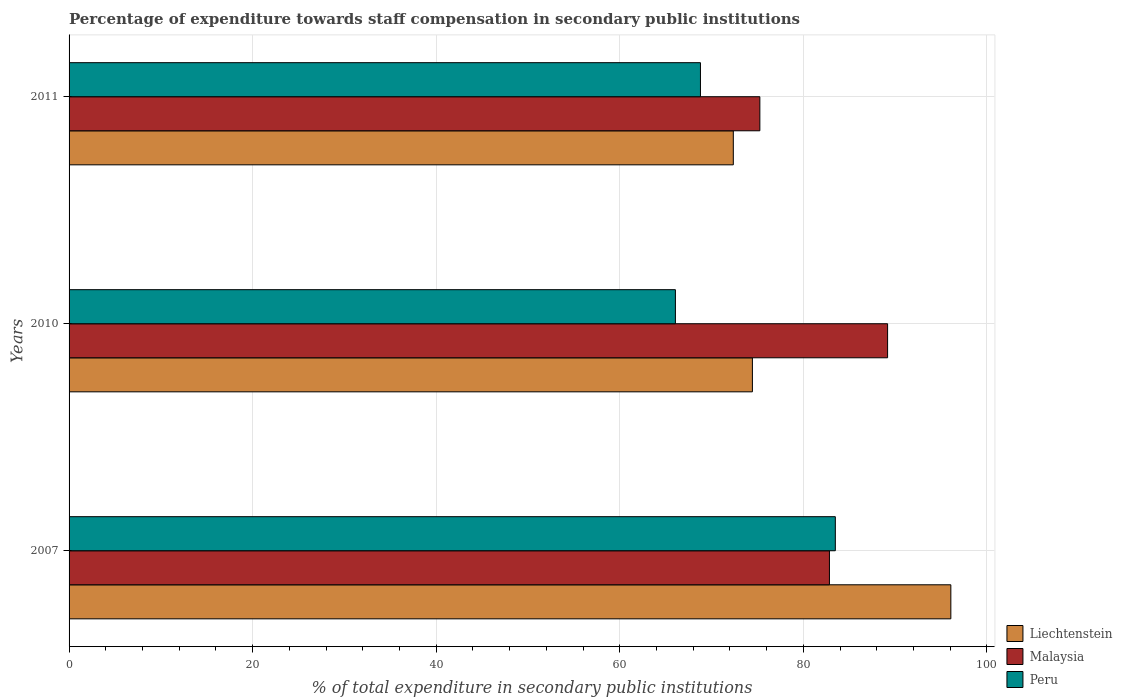How many different coloured bars are there?
Offer a very short reply. 3. Are the number of bars on each tick of the Y-axis equal?
Offer a terse response. Yes. How many bars are there on the 3rd tick from the top?
Give a very brief answer. 3. How many bars are there on the 2nd tick from the bottom?
Your response must be concise. 3. What is the label of the 2nd group of bars from the top?
Your response must be concise. 2010. What is the percentage of expenditure towards staff compensation in Peru in 2010?
Provide a succinct answer. 66.06. Across all years, what is the maximum percentage of expenditure towards staff compensation in Liechtenstein?
Offer a very short reply. 96.07. Across all years, what is the minimum percentage of expenditure towards staff compensation in Liechtenstein?
Provide a succinct answer. 72.37. In which year was the percentage of expenditure towards staff compensation in Malaysia maximum?
Give a very brief answer. 2010. What is the total percentage of expenditure towards staff compensation in Peru in the graph?
Your answer should be compact. 218.34. What is the difference between the percentage of expenditure towards staff compensation in Malaysia in 2007 and that in 2011?
Ensure brevity in your answer.  7.58. What is the difference between the percentage of expenditure towards staff compensation in Liechtenstein in 2010 and the percentage of expenditure towards staff compensation in Peru in 2007?
Offer a terse response. -9.03. What is the average percentage of expenditure towards staff compensation in Liechtenstein per year?
Ensure brevity in your answer.  80.97. In the year 2010, what is the difference between the percentage of expenditure towards staff compensation in Liechtenstein and percentage of expenditure towards staff compensation in Peru?
Give a very brief answer. 8.39. What is the ratio of the percentage of expenditure towards staff compensation in Liechtenstein in 2007 to that in 2011?
Your answer should be compact. 1.33. Is the difference between the percentage of expenditure towards staff compensation in Liechtenstein in 2007 and 2010 greater than the difference between the percentage of expenditure towards staff compensation in Peru in 2007 and 2010?
Provide a short and direct response. Yes. What is the difference between the highest and the second highest percentage of expenditure towards staff compensation in Liechtenstein?
Your response must be concise. 21.62. What is the difference between the highest and the lowest percentage of expenditure towards staff compensation in Liechtenstein?
Make the answer very short. 23.7. Is the sum of the percentage of expenditure towards staff compensation in Liechtenstein in 2010 and 2011 greater than the maximum percentage of expenditure towards staff compensation in Peru across all years?
Offer a terse response. Yes. What does the 2nd bar from the top in 2010 represents?
Make the answer very short. Malaysia. What does the 1st bar from the bottom in 2010 represents?
Your answer should be very brief. Liechtenstein. How many years are there in the graph?
Your response must be concise. 3. What is the difference between two consecutive major ticks on the X-axis?
Provide a succinct answer. 20. Does the graph contain any zero values?
Keep it short and to the point. No. How are the legend labels stacked?
Provide a short and direct response. Vertical. What is the title of the graph?
Offer a very short reply. Percentage of expenditure towards staff compensation in secondary public institutions. What is the label or title of the X-axis?
Your response must be concise. % of total expenditure in secondary public institutions. What is the label or title of the Y-axis?
Keep it short and to the point. Years. What is the % of total expenditure in secondary public institutions of Liechtenstein in 2007?
Your answer should be compact. 96.07. What is the % of total expenditure in secondary public institutions of Malaysia in 2007?
Your answer should be very brief. 82.85. What is the % of total expenditure in secondary public institutions of Peru in 2007?
Provide a succinct answer. 83.49. What is the % of total expenditure in secondary public institutions in Liechtenstein in 2010?
Offer a very short reply. 74.45. What is the % of total expenditure in secondary public institutions of Malaysia in 2010?
Provide a short and direct response. 89.18. What is the % of total expenditure in secondary public institutions of Peru in 2010?
Provide a short and direct response. 66.06. What is the % of total expenditure in secondary public institutions in Liechtenstein in 2011?
Offer a terse response. 72.37. What is the % of total expenditure in secondary public institutions of Malaysia in 2011?
Ensure brevity in your answer.  75.26. What is the % of total expenditure in secondary public institutions of Peru in 2011?
Your response must be concise. 68.79. Across all years, what is the maximum % of total expenditure in secondary public institutions in Liechtenstein?
Your answer should be compact. 96.07. Across all years, what is the maximum % of total expenditure in secondary public institutions in Malaysia?
Offer a terse response. 89.18. Across all years, what is the maximum % of total expenditure in secondary public institutions in Peru?
Ensure brevity in your answer.  83.49. Across all years, what is the minimum % of total expenditure in secondary public institutions of Liechtenstein?
Your answer should be compact. 72.37. Across all years, what is the minimum % of total expenditure in secondary public institutions of Malaysia?
Offer a terse response. 75.26. Across all years, what is the minimum % of total expenditure in secondary public institutions in Peru?
Ensure brevity in your answer.  66.06. What is the total % of total expenditure in secondary public institutions of Liechtenstein in the graph?
Ensure brevity in your answer.  242.9. What is the total % of total expenditure in secondary public institutions in Malaysia in the graph?
Give a very brief answer. 247.29. What is the total % of total expenditure in secondary public institutions of Peru in the graph?
Your answer should be very brief. 218.34. What is the difference between the % of total expenditure in secondary public institutions in Liechtenstein in 2007 and that in 2010?
Your response must be concise. 21.62. What is the difference between the % of total expenditure in secondary public institutions of Malaysia in 2007 and that in 2010?
Offer a very short reply. -6.34. What is the difference between the % of total expenditure in secondary public institutions of Peru in 2007 and that in 2010?
Provide a succinct answer. 17.42. What is the difference between the % of total expenditure in secondary public institutions in Liechtenstein in 2007 and that in 2011?
Provide a short and direct response. 23.7. What is the difference between the % of total expenditure in secondary public institutions of Malaysia in 2007 and that in 2011?
Ensure brevity in your answer.  7.58. What is the difference between the % of total expenditure in secondary public institutions in Peru in 2007 and that in 2011?
Make the answer very short. 14.7. What is the difference between the % of total expenditure in secondary public institutions of Liechtenstein in 2010 and that in 2011?
Make the answer very short. 2.08. What is the difference between the % of total expenditure in secondary public institutions of Malaysia in 2010 and that in 2011?
Your response must be concise. 13.92. What is the difference between the % of total expenditure in secondary public institutions of Peru in 2010 and that in 2011?
Your response must be concise. -2.73. What is the difference between the % of total expenditure in secondary public institutions in Liechtenstein in 2007 and the % of total expenditure in secondary public institutions in Malaysia in 2010?
Your response must be concise. 6.89. What is the difference between the % of total expenditure in secondary public institutions in Liechtenstein in 2007 and the % of total expenditure in secondary public institutions in Peru in 2010?
Make the answer very short. 30.01. What is the difference between the % of total expenditure in secondary public institutions in Malaysia in 2007 and the % of total expenditure in secondary public institutions in Peru in 2010?
Your answer should be compact. 16.78. What is the difference between the % of total expenditure in secondary public institutions in Liechtenstein in 2007 and the % of total expenditure in secondary public institutions in Malaysia in 2011?
Provide a succinct answer. 20.81. What is the difference between the % of total expenditure in secondary public institutions in Liechtenstein in 2007 and the % of total expenditure in secondary public institutions in Peru in 2011?
Make the answer very short. 27.28. What is the difference between the % of total expenditure in secondary public institutions in Malaysia in 2007 and the % of total expenditure in secondary public institutions in Peru in 2011?
Ensure brevity in your answer.  14.05. What is the difference between the % of total expenditure in secondary public institutions of Liechtenstein in 2010 and the % of total expenditure in secondary public institutions of Malaysia in 2011?
Make the answer very short. -0.81. What is the difference between the % of total expenditure in secondary public institutions of Liechtenstein in 2010 and the % of total expenditure in secondary public institutions of Peru in 2011?
Provide a short and direct response. 5.66. What is the difference between the % of total expenditure in secondary public institutions in Malaysia in 2010 and the % of total expenditure in secondary public institutions in Peru in 2011?
Provide a short and direct response. 20.39. What is the average % of total expenditure in secondary public institutions in Liechtenstein per year?
Ensure brevity in your answer.  80.97. What is the average % of total expenditure in secondary public institutions in Malaysia per year?
Your answer should be compact. 82.43. What is the average % of total expenditure in secondary public institutions in Peru per year?
Offer a terse response. 72.78. In the year 2007, what is the difference between the % of total expenditure in secondary public institutions in Liechtenstein and % of total expenditure in secondary public institutions in Malaysia?
Ensure brevity in your answer.  13.23. In the year 2007, what is the difference between the % of total expenditure in secondary public institutions of Liechtenstein and % of total expenditure in secondary public institutions of Peru?
Provide a succinct answer. 12.59. In the year 2007, what is the difference between the % of total expenditure in secondary public institutions of Malaysia and % of total expenditure in secondary public institutions of Peru?
Provide a short and direct response. -0.64. In the year 2010, what is the difference between the % of total expenditure in secondary public institutions of Liechtenstein and % of total expenditure in secondary public institutions of Malaysia?
Your answer should be compact. -14.73. In the year 2010, what is the difference between the % of total expenditure in secondary public institutions of Liechtenstein and % of total expenditure in secondary public institutions of Peru?
Provide a short and direct response. 8.39. In the year 2010, what is the difference between the % of total expenditure in secondary public institutions of Malaysia and % of total expenditure in secondary public institutions of Peru?
Keep it short and to the point. 23.12. In the year 2011, what is the difference between the % of total expenditure in secondary public institutions in Liechtenstein and % of total expenditure in secondary public institutions in Malaysia?
Your answer should be compact. -2.89. In the year 2011, what is the difference between the % of total expenditure in secondary public institutions of Liechtenstein and % of total expenditure in secondary public institutions of Peru?
Make the answer very short. 3.58. In the year 2011, what is the difference between the % of total expenditure in secondary public institutions of Malaysia and % of total expenditure in secondary public institutions of Peru?
Your answer should be very brief. 6.47. What is the ratio of the % of total expenditure in secondary public institutions in Liechtenstein in 2007 to that in 2010?
Your response must be concise. 1.29. What is the ratio of the % of total expenditure in secondary public institutions of Malaysia in 2007 to that in 2010?
Ensure brevity in your answer.  0.93. What is the ratio of the % of total expenditure in secondary public institutions in Peru in 2007 to that in 2010?
Your answer should be compact. 1.26. What is the ratio of the % of total expenditure in secondary public institutions in Liechtenstein in 2007 to that in 2011?
Your answer should be compact. 1.33. What is the ratio of the % of total expenditure in secondary public institutions in Malaysia in 2007 to that in 2011?
Provide a succinct answer. 1.1. What is the ratio of the % of total expenditure in secondary public institutions in Peru in 2007 to that in 2011?
Provide a short and direct response. 1.21. What is the ratio of the % of total expenditure in secondary public institutions of Liechtenstein in 2010 to that in 2011?
Give a very brief answer. 1.03. What is the ratio of the % of total expenditure in secondary public institutions of Malaysia in 2010 to that in 2011?
Your response must be concise. 1.18. What is the ratio of the % of total expenditure in secondary public institutions of Peru in 2010 to that in 2011?
Your answer should be compact. 0.96. What is the difference between the highest and the second highest % of total expenditure in secondary public institutions of Liechtenstein?
Keep it short and to the point. 21.62. What is the difference between the highest and the second highest % of total expenditure in secondary public institutions of Malaysia?
Make the answer very short. 6.34. What is the difference between the highest and the second highest % of total expenditure in secondary public institutions of Peru?
Give a very brief answer. 14.7. What is the difference between the highest and the lowest % of total expenditure in secondary public institutions in Liechtenstein?
Your answer should be very brief. 23.7. What is the difference between the highest and the lowest % of total expenditure in secondary public institutions in Malaysia?
Your answer should be compact. 13.92. What is the difference between the highest and the lowest % of total expenditure in secondary public institutions in Peru?
Offer a very short reply. 17.42. 